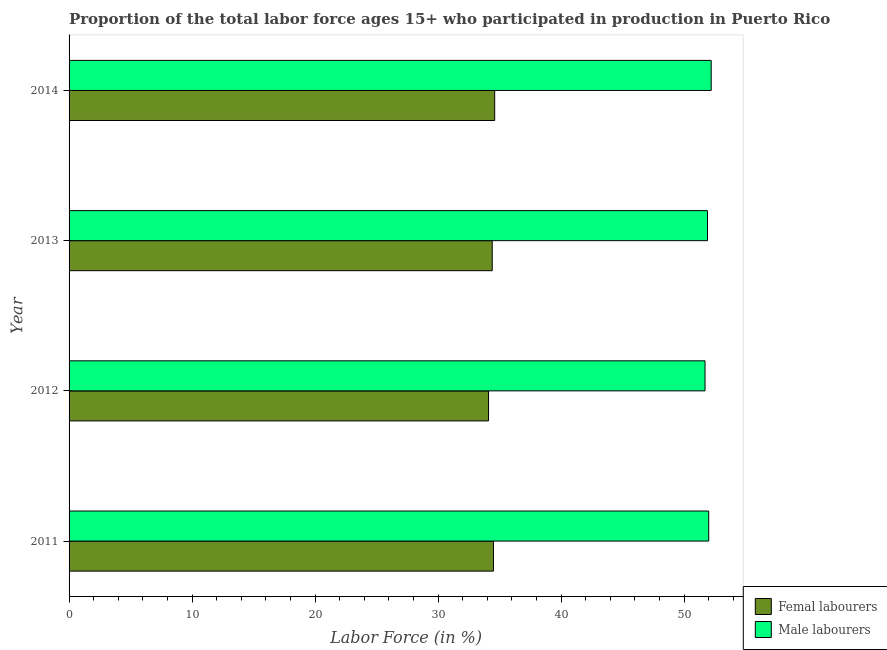How many different coloured bars are there?
Provide a short and direct response. 2. How many bars are there on the 3rd tick from the bottom?
Ensure brevity in your answer.  2. What is the label of the 3rd group of bars from the top?
Offer a terse response. 2012. In how many cases, is the number of bars for a given year not equal to the number of legend labels?
Offer a very short reply. 0. What is the percentage of female labor force in 2012?
Provide a succinct answer. 34.1. Across all years, what is the maximum percentage of male labour force?
Provide a succinct answer. 52.2. Across all years, what is the minimum percentage of male labour force?
Your answer should be compact. 51.7. In which year was the percentage of male labour force minimum?
Ensure brevity in your answer.  2012. What is the total percentage of female labor force in the graph?
Provide a short and direct response. 137.6. What is the difference between the percentage of male labour force in 2011 and that in 2013?
Your answer should be compact. 0.1. What is the difference between the percentage of female labor force in 2011 and the percentage of male labour force in 2012?
Provide a succinct answer. -17.2. What is the average percentage of female labor force per year?
Keep it short and to the point. 34.4. Is the percentage of male labour force in 2013 less than that in 2014?
Ensure brevity in your answer.  Yes. What is the difference between the highest and the lowest percentage of female labor force?
Provide a succinct answer. 0.5. In how many years, is the percentage of female labor force greater than the average percentage of female labor force taken over all years?
Your response must be concise. 3. What does the 1st bar from the top in 2014 represents?
Keep it short and to the point. Male labourers. What does the 1st bar from the bottom in 2012 represents?
Provide a short and direct response. Femal labourers. How many bars are there?
Make the answer very short. 8. How many years are there in the graph?
Offer a very short reply. 4. What is the difference between two consecutive major ticks on the X-axis?
Provide a succinct answer. 10. Are the values on the major ticks of X-axis written in scientific E-notation?
Your answer should be compact. No. Does the graph contain any zero values?
Your answer should be compact. No. Does the graph contain grids?
Your response must be concise. No. How many legend labels are there?
Offer a terse response. 2. How are the legend labels stacked?
Your answer should be very brief. Vertical. What is the title of the graph?
Ensure brevity in your answer.  Proportion of the total labor force ages 15+ who participated in production in Puerto Rico. What is the label or title of the X-axis?
Ensure brevity in your answer.  Labor Force (in %). What is the label or title of the Y-axis?
Make the answer very short. Year. What is the Labor Force (in %) in Femal labourers in 2011?
Offer a terse response. 34.5. What is the Labor Force (in %) in Femal labourers in 2012?
Provide a succinct answer. 34.1. What is the Labor Force (in %) in Male labourers in 2012?
Offer a very short reply. 51.7. What is the Labor Force (in %) of Femal labourers in 2013?
Ensure brevity in your answer.  34.4. What is the Labor Force (in %) in Male labourers in 2013?
Provide a short and direct response. 51.9. What is the Labor Force (in %) in Femal labourers in 2014?
Provide a succinct answer. 34.6. What is the Labor Force (in %) of Male labourers in 2014?
Your response must be concise. 52.2. Across all years, what is the maximum Labor Force (in %) in Femal labourers?
Ensure brevity in your answer.  34.6. Across all years, what is the maximum Labor Force (in %) of Male labourers?
Offer a terse response. 52.2. Across all years, what is the minimum Labor Force (in %) in Femal labourers?
Make the answer very short. 34.1. Across all years, what is the minimum Labor Force (in %) in Male labourers?
Ensure brevity in your answer.  51.7. What is the total Labor Force (in %) in Femal labourers in the graph?
Offer a terse response. 137.6. What is the total Labor Force (in %) of Male labourers in the graph?
Keep it short and to the point. 207.8. What is the difference between the Labor Force (in %) of Male labourers in 2011 and that in 2012?
Offer a very short reply. 0.3. What is the difference between the Labor Force (in %) of Femal labourers in 2011 and that in 2013?
Your response must be concise. 0.1. What is the difference between the Labor Force (in %) of Femal labourers in 2011 and that in 2014?
Make the answer very short. -0.1. What is the difference between the Labor Force (in %) in Male labourers in 2011 and that in 2014?
Provide a short and direct response. -0.2. What is the difference between the Labor Force (in %) of Femal labourers in 2012 and that in 2014?
Your answer should be compact. -0.5. What is the difference between the Labor Force (in %) of Femal labourers in 2013 and that in 2014?
Provide a short and direct response. -0.2. What is the difference between the Labor Force (in %) of Femal labourers in 2011 and the Labor Force (in %) of Male labourers in 2012?
Ensure brevity in your answer.  -17.2. What is the difference between the Labor Force (in %) of Femal labourers in 2011 and the Labor Force (in %) of Male labourers in 2013?
Your answer should be compact. -17.4. What is the difference between the Labor Force (in %) in Femal labourers in 2011 and the Labor Force (in %) in Male labourers in 2014?
Your answer should be very brief. -17.7. What is the difference between the Labor Force (in %) of Femal labourers in 2012 and the Labor Force (in %) of Male labourers in 2013?
Provide a succinct answer. -17.8. What is the difference between the Labor Force (in %) of Femal labourers in 2012 and the Labor Force (in %) of Male labourers in 2014?
Make the answer very short. -18.1. What is the difference between the Labor Force (in %) of Femal labourers in 2013 and the Labor Force (in %) of Male labourers in 2014?
Offer a very short reply. -17.8. What is the average Labor Force (in %) in Femal labourers per year?
Give a very brief answer. 34.4. What is the average Labor Force (in %) of Male labourers per year?
Give a very brief answer. 51.95. In the year 2011, what is the difference between the Labor Force (in %) of Femal labourers and Labor Force (in %) of Male labourers?
Your answer should be very brief. -17.5. In the year 2012, what is the difference between the Labor Force (in %) of Femal labourers and Labor Force (in %) of Male labourers?
Provide a succinct answer. -17.6. In the year 2013, what is the difference between the Labor Force (in %) of Femal labourers and Labor Force (in %) of Male labourers?
Ensure brevity in your answer.  -17.5. In the year 2014, what is the difference between the Labor Force (in %) in Femal labourers and Labor Force (in %) in Male labourers?
Make the answer very short. -17.6. What is the ratio of the Labor Force (in %) of Femal labourers in 2011 to that in 2012?
Offer a terse response. 1.01. What is the ratio of the Labor Force (in %) in Femal labourers in 2011 to that in 2013?
Your answer should be compact. 1. What is the ratio of the Labor Force (in %) of Male labourers in 2011 to that in 2013?
Keep it short and to the point. 1. What is the ratio of the Labor Force (in %) in Male labourers in 2011 to that in 2014?
Provide a succinct answer. 1. What is the ratio of the Labor Force (in %) in Femal labourers in 2012 to that in 2013?
Your answer should be compact. 0.99. What is the ratio of the Labor Force (in %) in Femal labourers in 2012 to that in 2014?
Offer a terse response. 0.99. What is the ratio of the Labor Force (in %) of Male labourers in 2012 to that in 2014?
Your answer should be compact. 0.99. What is the ratio of the Labor Force (in %) of Femal labourers in 2013 to that in 2014?
Your answer should be very brief. 0.99. What is the difference between the highest and the second highest Labor Force (in %) of Femal labourers?
Your response must be concise. 0.1. What is the difference between the highest and the second highest Labor Force (in %) in Male labourers?
Ensure brevity in your answer.  0.2. What is the difference between the highest and the lowest Labor Force (in %) in Male labourers?
Make the answer very short. 0.5. 